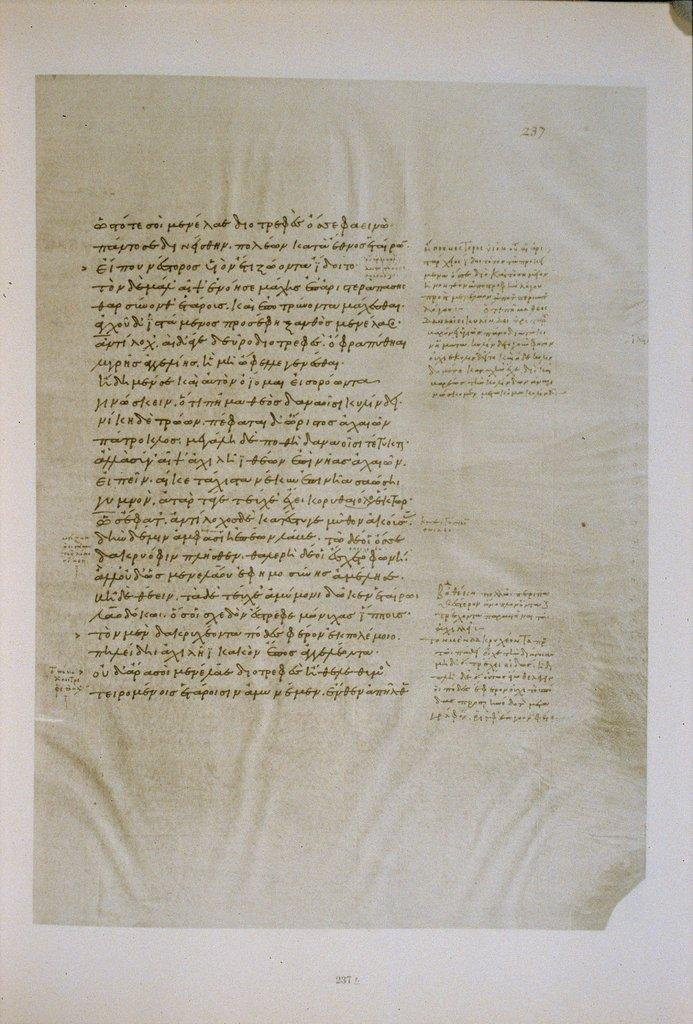<image>
Summarize the visual content of the image. Page 237 from an old book has been mounted on a white paper. 